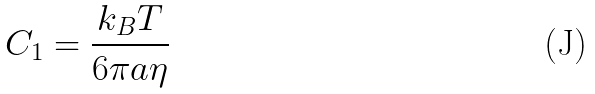Convert formula to latex. <formula><loc_0><loc_0><loc_500><loc_500>C _ { 1 } = \frac { k _ { B } T } { 6 \pi a \eta }</formula> 